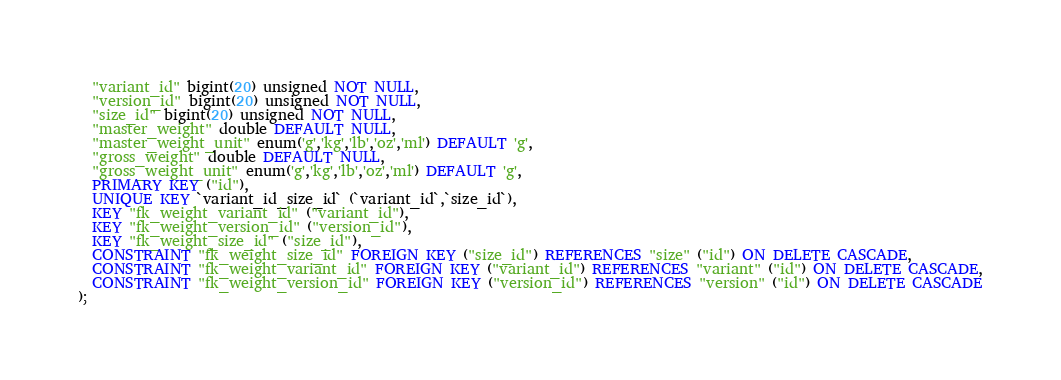<code> <loc_0><loc_0><loc_500><loc_500><_SQL_>  "variant_id" bigint(20) unsigned NOT NULL,
  "version_id" bigint(20) unsigned NOT NULL,
  "size_id" bigint(20) unsigned NOT NULL,
  "master_weight" double DEFAULT NULL,
  "master_weight_unit" enum('g','kg','lb','oz','ml') DEFAULT 'g',
  "gross_weight" double DEFAULT NULL,
  "gross_weight_unit" enum('g','kg','lb','oz','ml') DEFAULT 'g',
  PRIMARY KEY ("id"),
  UNIQUE KEY `variant_id_size_id` (`variant_id`,`size_id`),
  KEY "fk_weight_variant_id" ("variant_id"),
  KEY "fk_weight_version_id" ("version_id"),
  KEY "fk_weight_size_id" ("size_id"),
  CONSTRAINT "fk_weight_size_id" FOREIGN KEY ("size_id") REFERENCES "size" ("id") ON DELETE CASCADE,
  CONSTRAINT "fk_weight_variant_id" FOREIGN KEY ("variant_id") REFERENCES "variant" ("id") ON DELETE CASCADE,
  CONSTRAINT "fk_weight_version_id" FOREIGN KEY ("version_id") REFERENCES "version" ("id") ON DELETE CASCADE
);</code> 